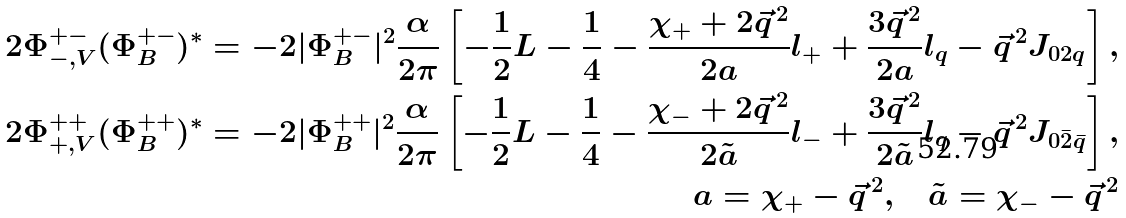<formula> <loc_0><loc_0><loc_500><loc_500>2 \Phi ^ { + - } _ { - , V } ( \Phi ^ { + - } _ { B } ) ^ { * } = - 2 | \Phi _ { B } ^ { + - } | ^ { 2 } \frac { \alpha } { 2 \pi } \left [ - \frac { 1 } { 2 } L - \frac { 1 } { 4 } - \frac { \chi _ { + } + 2 \vec { q } ^ { \, 2 } } { 2 a } l _ { + } + \frac { 3 \vec { q } ^ { \, 2 } } { 2 a } l _ { q } - \vec { q } ^ { \, 2 } J _ { 0 2 q } \right ] , \\ 2 \Phi ^ { + + } _ { + , V } ( \Phi ^ { + + } _ { B } ) ^ { * } = - 2 | \Phi _ { B } ^ { + + } | ^ { 2 } \frac { \alpha } { 2 \pi } \left [ - \frac { 1 } { 2 } L - \frac { 1 } { 4 } - \frac { \chi _ { - } + 2 \vec { q } ^ { \, 2 } } { 2 \tilde { a } } l _ { - } + \frac { 3 \vec { q } ^ { \, 2 } } { 2 \tilde { a } } l _ { q } - \vec { q } ^ { \, 2 } J _ { 0 \bar { 2 } \bar { q } } \right ] , \\ a = \chi _ { + } - \vec { q } ^ { \, 2 } , \quad \tilde { a } = \chi _ { - } - \vec { q } ^ { \, 2 }</formula> 